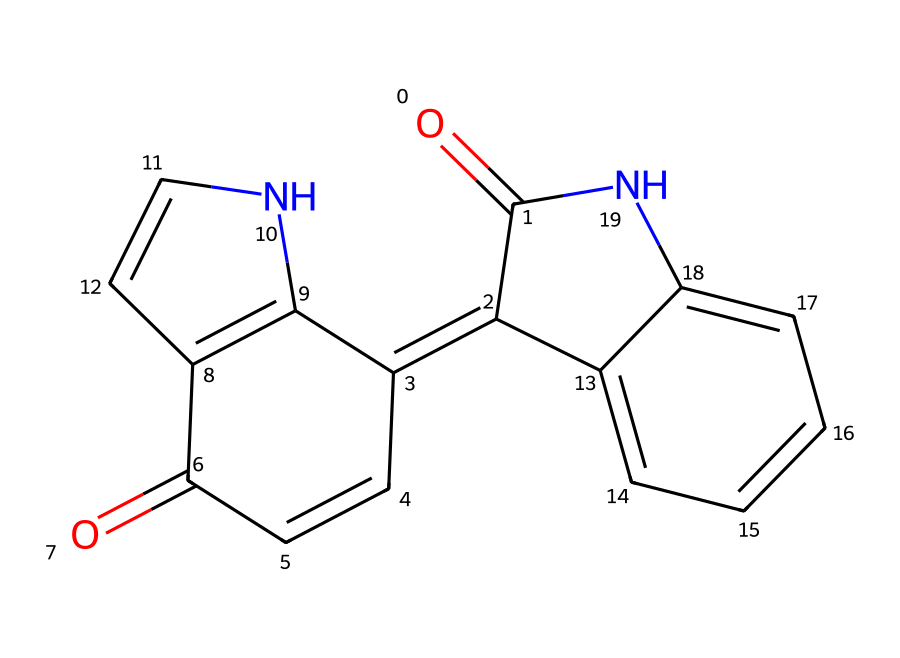What is the molecular formula of the dye? To determine the molecular formula, we count the number of each type of atom present in the chemical structure. This dye contains carbon (C), hydrogen (H), nitrogen (N), and oxygen (O) atoms. The counts are: 16 carbon atoms, 10 hydrogen atoms, 2 nitrogen atoms, and 2 oxygen atoms. Therefore, the molecular formula is C16H10N2O2.
Answer: C16H10N2O2 How many nitrogen atoms are present in the structure? By examining the molecular structure, we can identify the presence of nitrogen atoms. There are two nitrogen atoms visible in the structure.
Answer: 2 What type of functional groups are present? Identifying functional groups involves looking for characteristic atoms or groups that define reactivity. Here, we notice two carbonyl groups (C=O) indicative of ketone functionality in addition to nitrogen atoms suggesting amine groups are present.
Answer: carbonyl and amine What is the significance of the ring structure in the dye? The presence of multiple ring structures indicates aromatic characteristics, which contribute to color properties and stability of the dye. The fused rings allow for delocalization of electrons, enhancing color intensity and lightfastness.
Answer: aromatic stability Which atoms in the dye are likely responsible for its color? The color in dyes typically originates from the conjugated system of double bonds in the structure that allows for electron delocalization, often found in the aromatic rings. In this case, the carbon atoms in the ring structure can contribute to color due to their aromatic nature.
Answer: carbon atoms in rings What kind of chemical is this compound classified as? Based on the presence of conjugated double bonds and the functional groups characterized, this compound is classified as an organic dye, specifically an indigo dye due to its historical use and structural characteristics.
Answer: organic dye (indigo) 